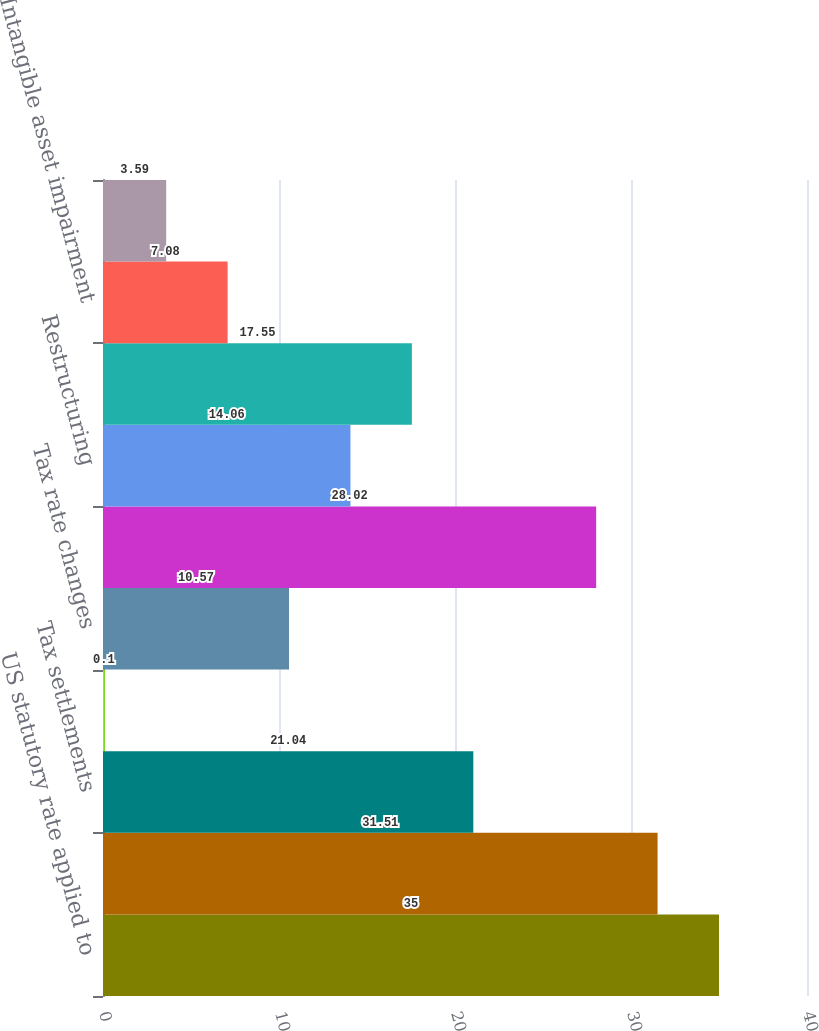<chart> <loc_0><loc_0><loc_500><loc_500><bar_chart><fcel>US statutory rate applied to<fcel>Foreign earnings<fcel>Tax settlements<fcel>Unremitted foreign earnings<fcel>Tax rate changes<fcel>Amortization of purchase<fcel>Restructuring<fcel>US health care reform<fcel>Intangible asset impairment<fcel>State taxes<nl><fcel>35<fcel>31.51<fcel>21.04<fcel>0.1<fcel>10.57<fcel>28.02<fcel>14.06<fcel>17.55<fcel>7.08<fcel>3.59<nl></chart> 